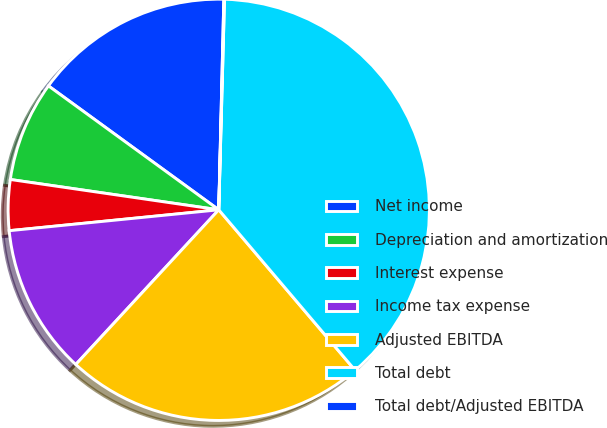<chart> <loc_0><loc_0><loc_500><loc_500><pie_chart><fcel>Net income<fcel>Depreciation and amortization<fcel>Interest expense<fcel>Income tax expense<fcel>Adjusted EBITDA<fcel>Total debt<fcel>Total debt/Adjusted EBITDA<nl><fcel>15.37%<fcel>7.71%<fcel>3.88%<fcel>11.54%<fcel>23.08%<fcel>38.35%<fcel>0.05%<nl></chart> 